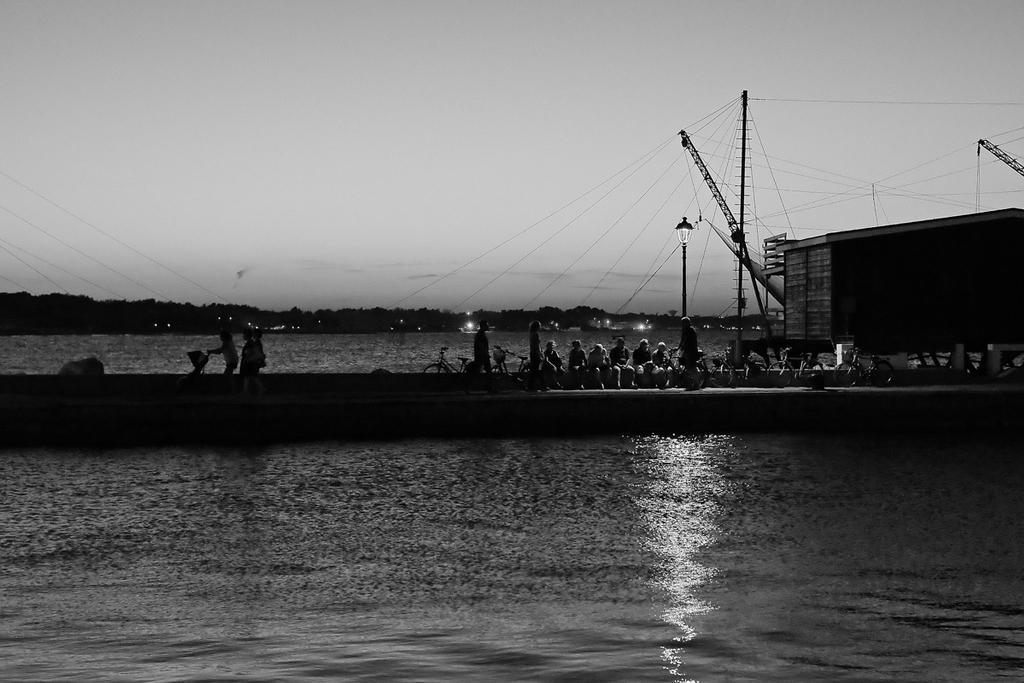What is visible in the image? Water, people, bicycles, a wall, poles, a light, wires, trees, and the sky are visible in the image. Can you describe the people in the image? The people are present in the distance. What type of structure is the wall in the image? The information provided does not specify the type of wall. What is the purpose of the light in the image? The purpose of the light is not specified in the provided facts. What is the background of the image? The background of the image includes trees and the sky. What type of insect can be seen crawling on the quartz in the image? There is no insect or quartz present in the image. What type of game are the people playing in the image? There is no indication of any game or play activity in the image. 